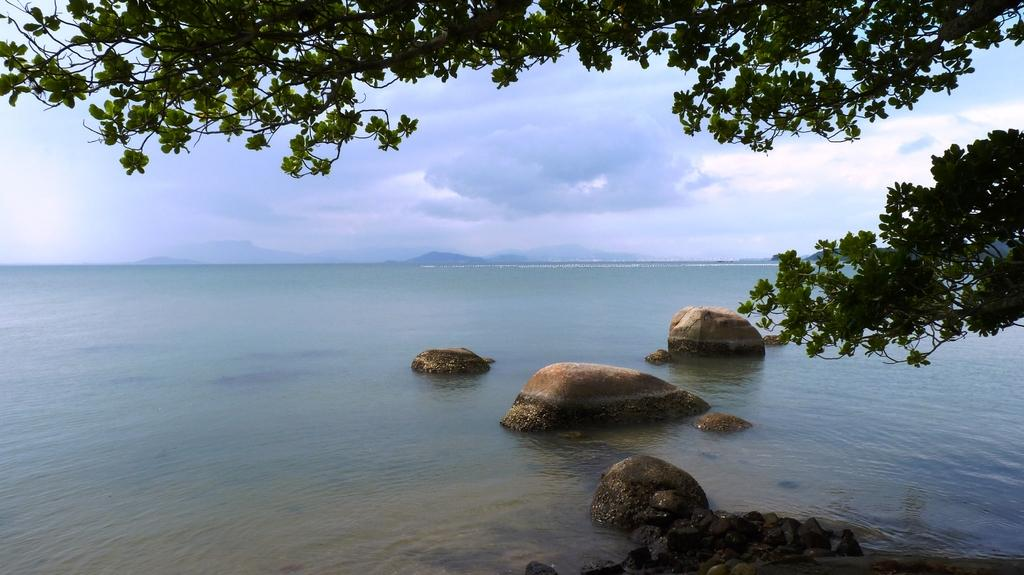What is the primary element visible in the image? There is water in the image. What other natural elements can be seen in the image? There are rocks, stones, and trees visible in the image. What is visible in the background of the image? The sky is visible in the background of the image. What is the title of the work displayed in the image? There is no artwork or title present in the image; it features natural elements such as water, rocks, stones, trees, and the sky. 